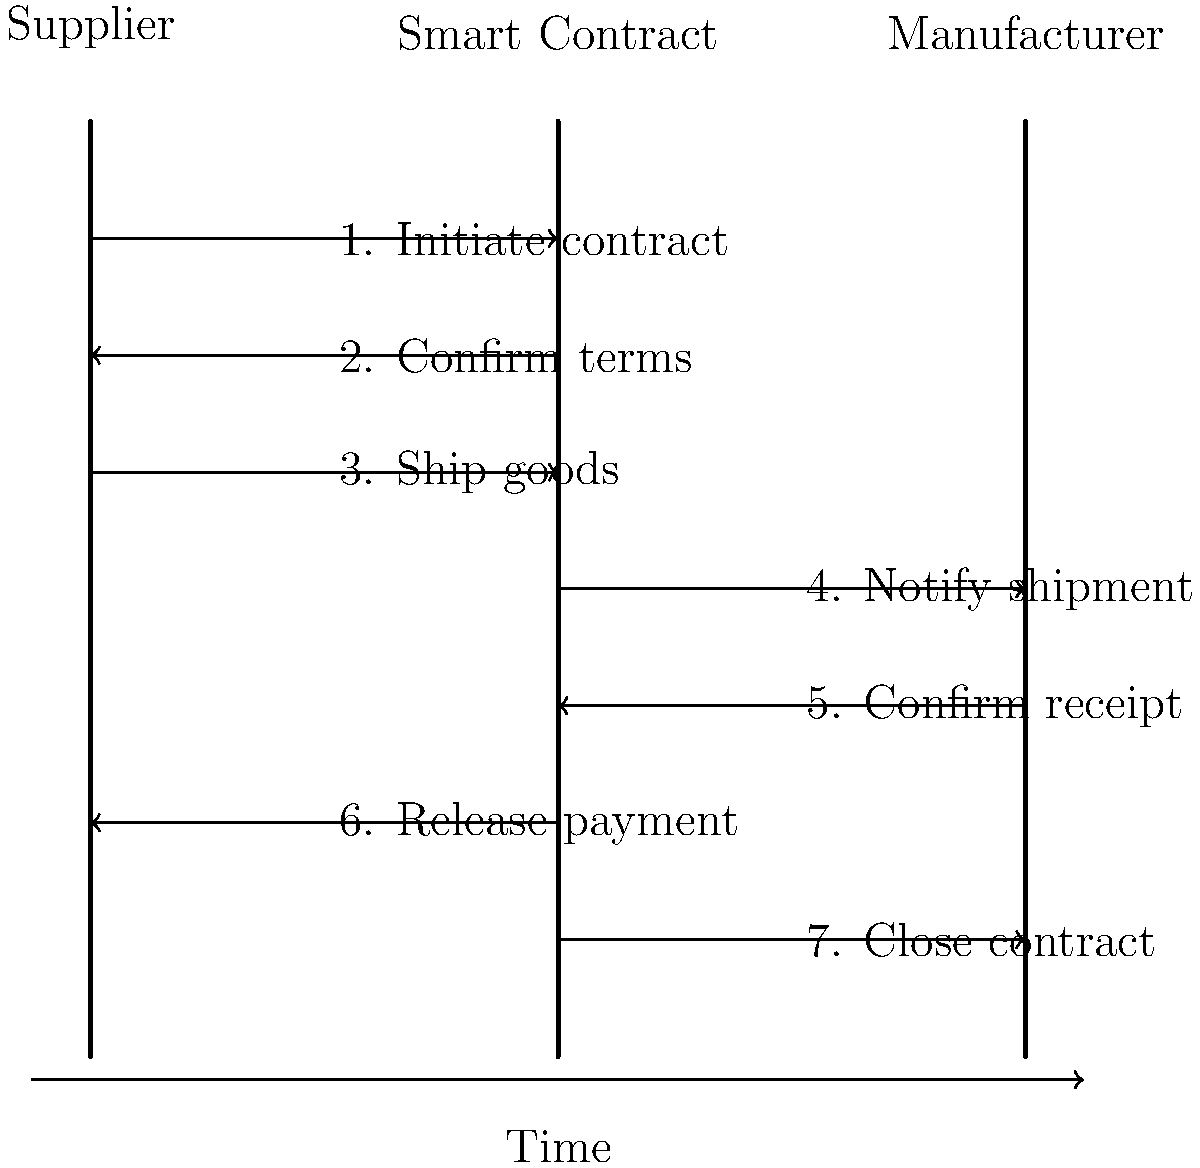Based on the sequence diagram illustrating smart contract execution in a supply chain transaction between a supplier and manufacturer, what is the correct order of events after the contract terms are confirmed? To answer this question, we need to analyze the sequence diagram step by step:

1. The process starts with the supplier initiating the smart contract.
2. The smart contract confirms the terms with the supplier.
3. After confirmation, the supplier ships the goods.
4. The smart contract notifies the manufacturer of the shipment.
5. Upon receiving the goods, the manufacturer confirms receipt to the smart contract.
6. The smart contract releases payment to the supplier.
7. Finally, the smart contract closes the transaction.

The question asks for the correct order of events after the contract terms are confirmed (step 2). Therefore, we need to focus on steps 3-7.

The correct sequence after contract confirmation is:
a) Supplier ships goods
b) Smart contract notifies manufacturer of shipment
c) Manufacturer confirms receipt
d) Smart contract releases payment
e) Smart contract closes the transaction
Answer: Ship goods, notify shipment, confirm receipt, release payment, close contract 